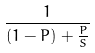Convert formula to latex. <formula><loc_0><loc_0><loc_500><loc_500>\frac { 1 } { ( 1 - P ) + \frac { P } { S } }</formula> 